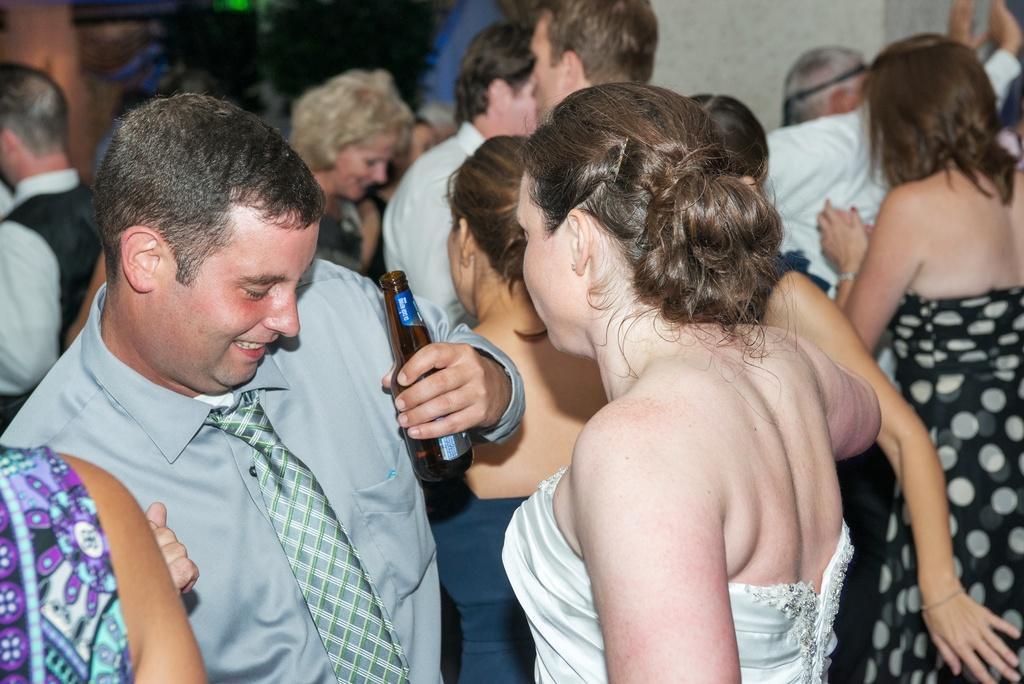In one or two sentences, can you explain what this image depicts? people are standing. the person at the left is wearing a tie and holding a brown glass bottle in his hand. behind them there is white wall at the right. the person at the front is wearing a white dress. 